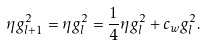<formula> <loc_0><loc_0><loc_500><loc_500>\eta g _ { l + 1 } ^ { 2 } = \eta g _ { l } ^ { 2 } = \frac { 1 } { 4 } \eta g _ { l } ^ { 2 } + c _ { w } g _ { l } ^ { 2 } .</formula> 